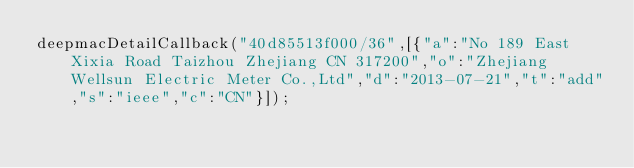<code> <loc_0><loc_0><loc_500><loc_500><_JavaScript_>deepmacDetailCallback("40d85513f000/36",[{"a":"No 189 East Xixia Road Taizhou Zhejiang CN 317200","o":"Zhejiang Wellsun Electric Meter Co.,Ltd","d":"2013-07-21","t":"add","s":"ieee","c":"CN"}]);
</code> 